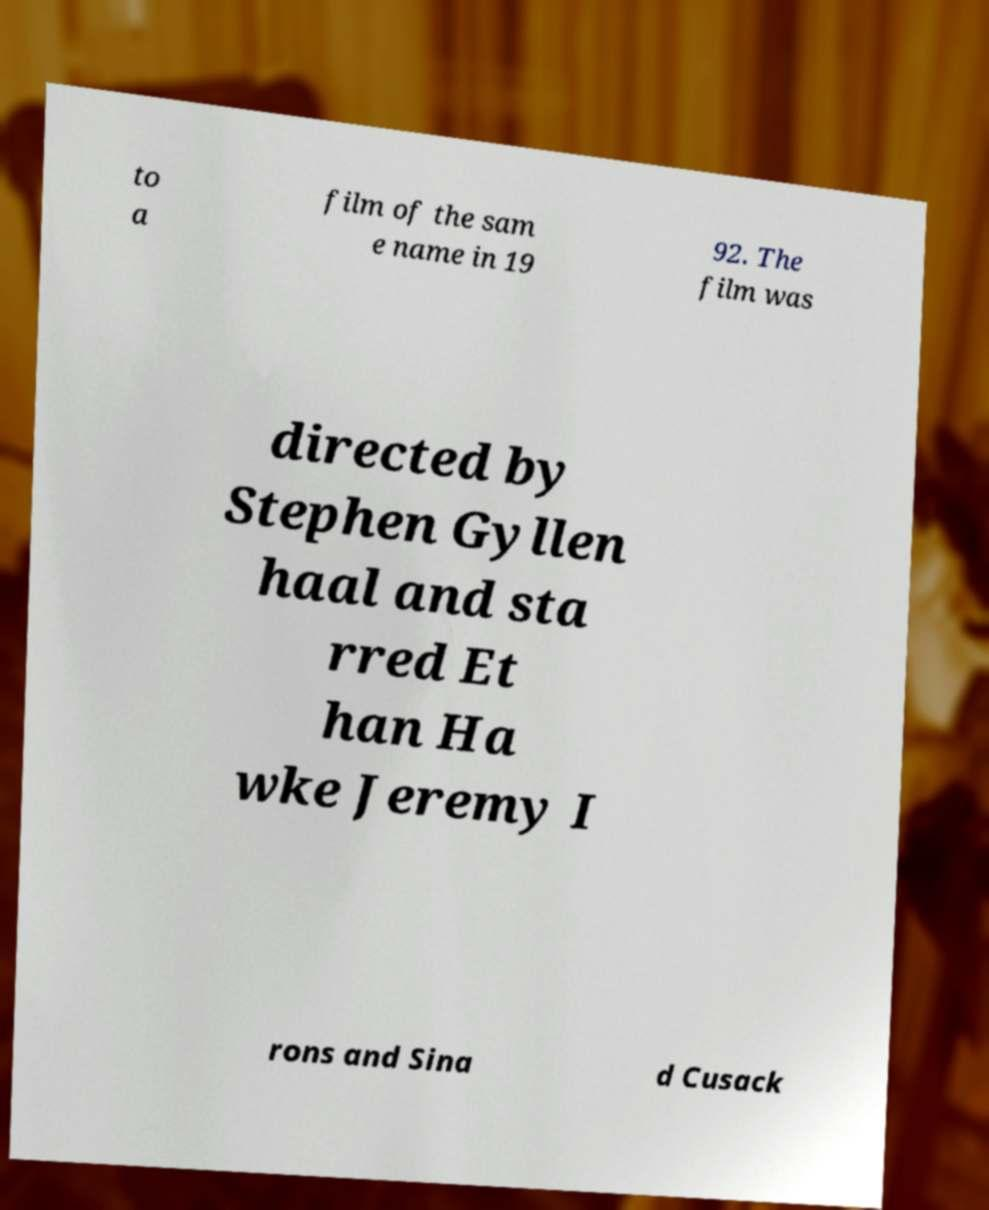Can you accurately transcribe the text from the provided image for me? to a film of the sam e name in 19 92. The film was directed by Stephen Gyllen haal and sta rred Et han Ha wke Jeremy I rons and Sina d Cusack 